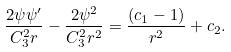Convert formula to latex. <formula><loc_0><loc_0><loc_500><loc_500>\frac { 2 \psi \psi ^ { \prime } } { C _ { 3 } ^ { 2 } r } - \frac { 2 \psi ^ { 2 } } { C _ { 3 } ^ { 2 } r ^ { 2 } } = \frac { ( c _ { 1 } - 1 ) } { r ^ { 2 } } + c _ { 2 } .</formula> 